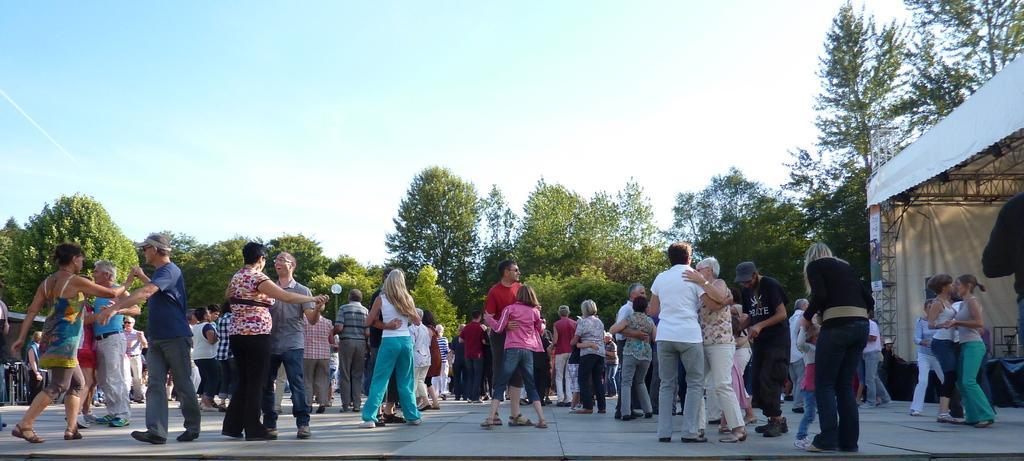Please provide a concise description of this image. In this image we can see persons standing on the floor. In the background there are iron grills, tent, trees and sky. 